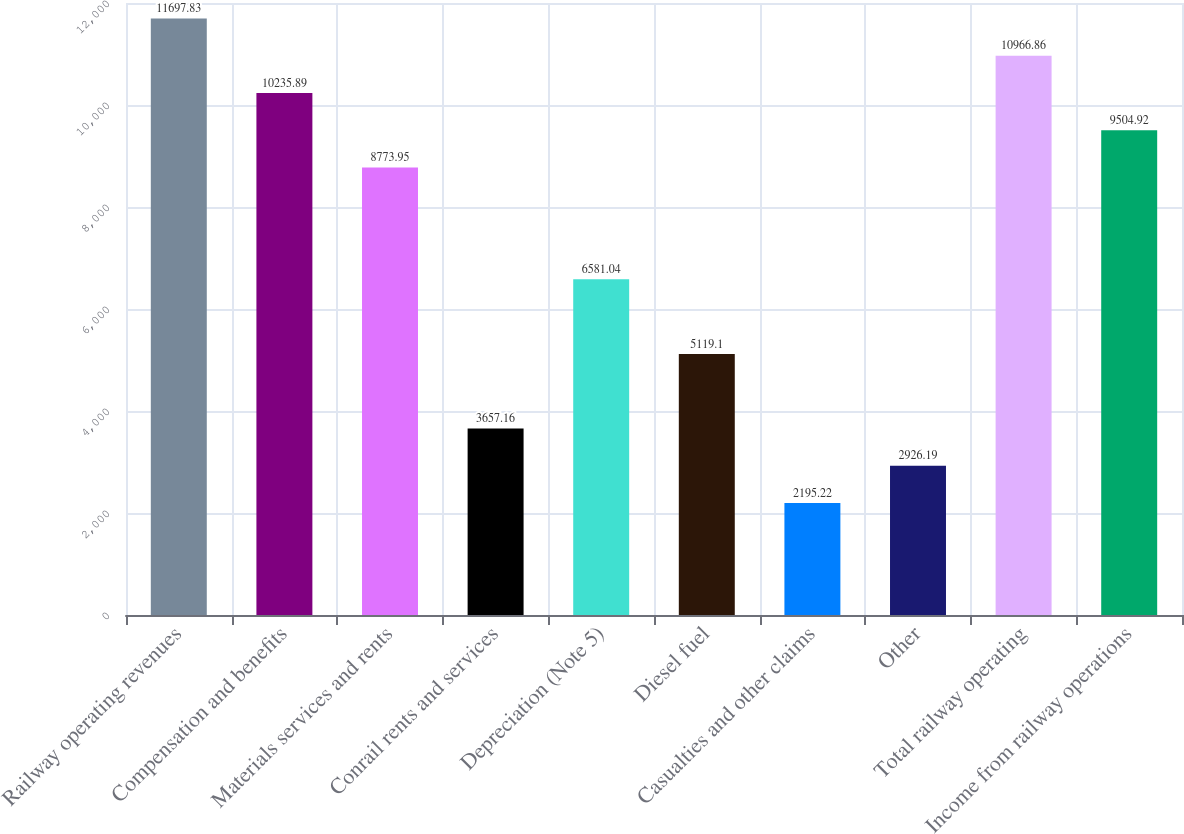Convert chart to OTSL. <chart><loc_0><loc_0><loc_500><loc_500><bar_chart><fcel>Railway operating revenues<fcel>Compensation and benefits<fcel>Materials services and rents<fcel>Conrail rents and services<fcel>Depreciation (Note 5)<fcel>Diesel fuel<fcel>Casualties and other claims<fcel>Other<fcel>Total railway operating<fcel>Income from railway operations<nl><fcel>11697.8<fcel>10235.9<fcel>8773.95<fcel>3657.16<fcel>6581.04<fcel>5119.1<fcel>2195.22<fcel>2926.19<fcel>10966.9<fcel>9504.92<nl></chart> 